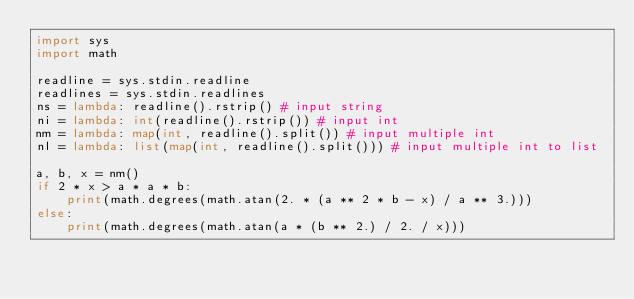<code> <loc_0><loc_0><loc_500><loc_500><_Python_>import sys
import math

readline = sys.stdin.readline
readlines = sys.stdin.readlines
ns = lambda: readline().rstrip() # input string
ni = lambda: int(readline().rstrip()) # input int
nm = lambda: map(int, readline().split()) # input multiple int 
nl = lambda: list(map(int, readline().split())) # input multiple int to list

a, b, x = nm()
if 2 * x > a * a * b:
    print(math.degrees(math.atan(2. * (a ** 2 * b - x) / a ** 3.)))
else:
    print(math.degrees(math.atan(a * (b ** 2.) / 2. / x)))</code> 